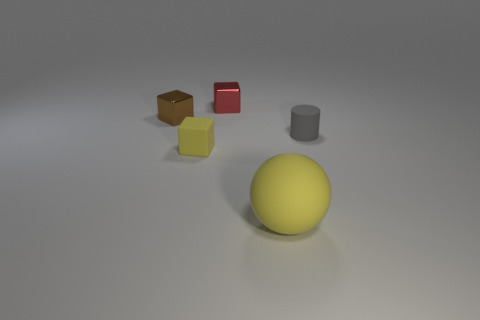Subtract all matte cubes. How many cubes are left? 2 Subtract 1 blocks. How many blocks are left? 2 Add 3 tiny metallic cubes. How many objects exist? 8 Subtract all blocks. How many objects are left? 2 Add 5 red metallic blocks. How many red metallic blocks are left? 6 Add 5 tiny objects. How many tiny objects exist? 9 Subtract 0 purple cylinders. How many objects are left? 5 Subtract all small green metal things. Subtract all spheres. How many objects are left? 4 